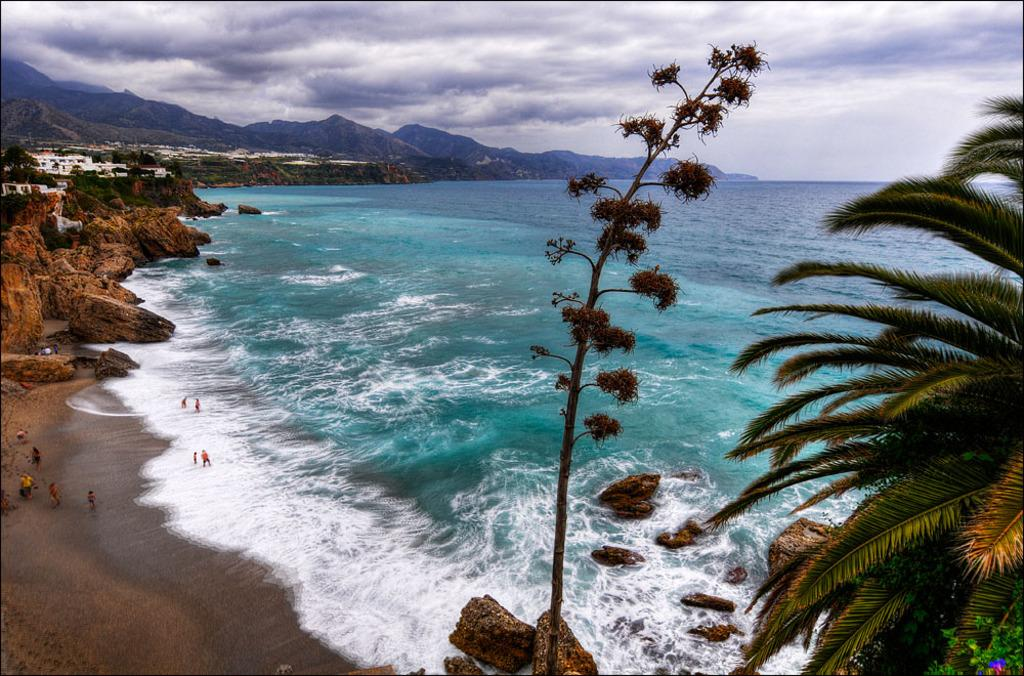What type of terrain is visible in the image? Ground is visible in the image, along with water, rocks, and trees. How many people can be seen in the image? There are persons standing in the image. What type of structures are present in the image? There are buildings in the image. What natural features can be seen in the background of the image? Mountains and the sky are visible in the background of the image. What type of chess pieces can be seen on the ground in the image? There are no chess pieces visible in the image. How does the judge in the image react to the rainstorm? There is no judge or rainstorm present in the image. 